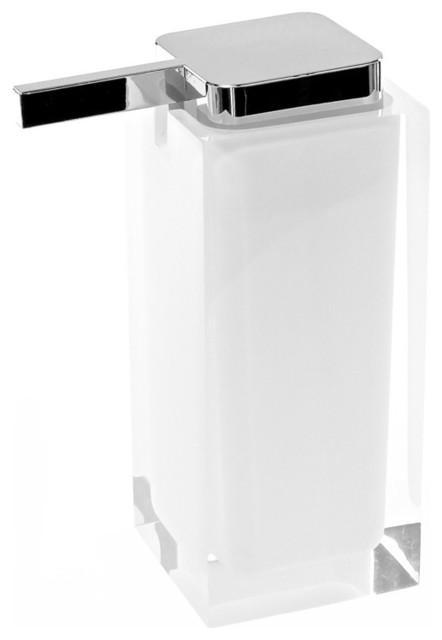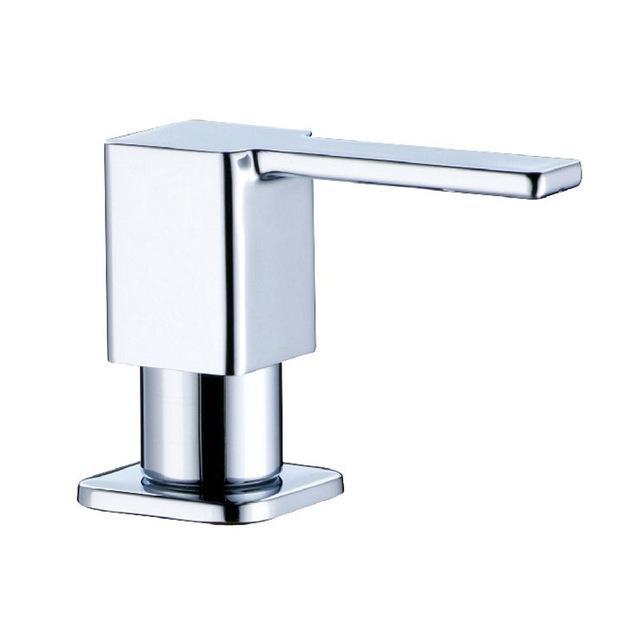The first image is the image on the left, the second image is the image on the right. Assess this claim about the two images: "The rectangular dispenser on the left is taller than the white dispenser on the right.". Correct or not? Answer yes or no. No. The first image is the image on the left, the second image is the image on the right. For the images displayed, is the sentence "The nozzles of the dispensers in the left and right images face generally away from each other." factually correct? Answer yes or no. Yes. 